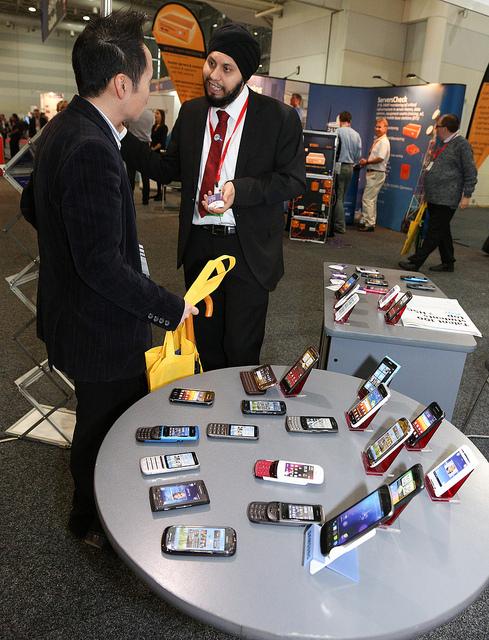Is there any food on the table?
Write a very short answer. No. In what faith does the salesperson offering the telephones seem to belong?
Answer briefly. Islam. Is this a super center?
Short answer required. No. What is on display in the foreground?
Write a very short answer. Cell phones. 